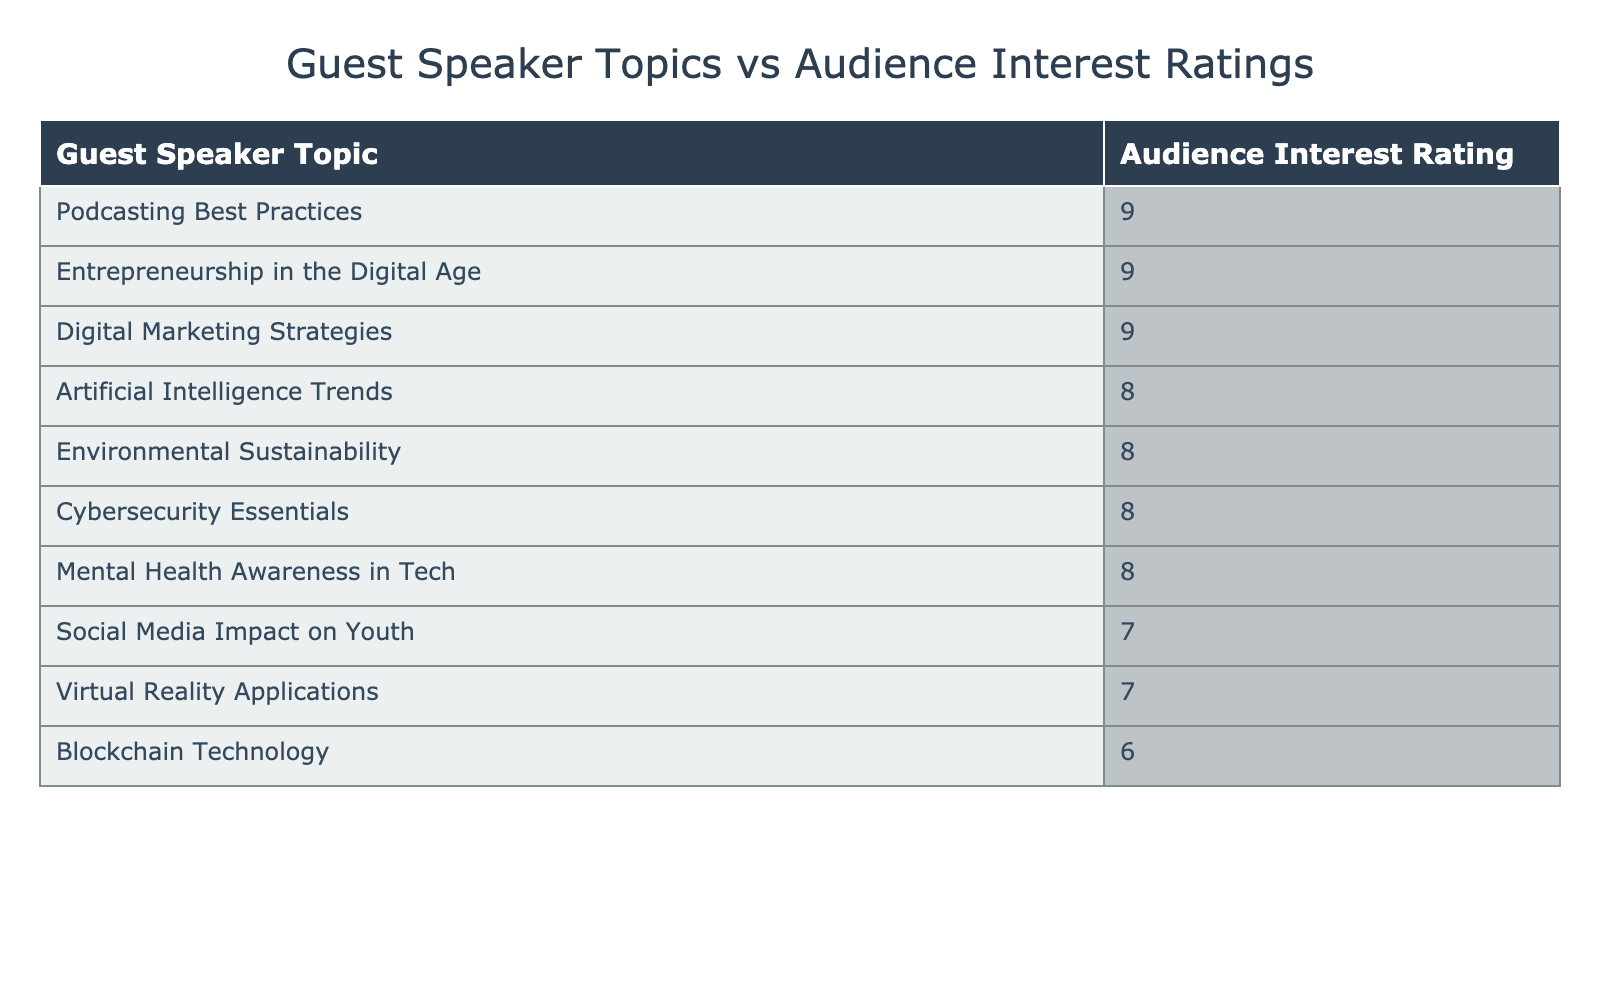What is the highest audience interest rating and which topic does it correspond to? The highest audience interest rating in the table is 9. It corresponds to the topics "Podcasting Best Practices," "Entrepreneurship in the Digital Age," and "Digital Marketing Strategies," which all share this rating.
Answer: 9 (Podcasting Best Practices, Entrepreneurship in the Digital Age, Digital Marketing Strategies) What is the audience interest rating for "Virtual Reality Applications"? The audience interest rating for "Virtual Reality Applications" is listed directly in the table as 7.
Answer: 7 How many topics received an interest rating of 8 or higher? To find this, I can count how many topics are listed with ratings of 8 or above in the table. The topics with ratings of 8 are: "Artificial Intelligence Trends," "Environmental Sustainability," "Cybersecurity Essentials," and "Mental Health Awareness in Tech." The topics with a rating of 9 are "Podcasting Best Practices," "Entrepreneurship in the Digital Age," and "Digital Marketing Strategies." In total, there are 7 topics that received 8 or higher.
Answer: 7 Was "Blockchain Technology" rated lower than "Social Media Impact on Youth"? "Blockchain Technology" has an audience interest rating of 6, while "Social Media Impact on Youth" has a rating of 7. Since 6 is less than 7, it confirms that "Blockchain Technology" was rated lower.
Answer: Yes What is the average audience interest rating across all topics? I will sum the ratings for each topic: 8 + 9 + 7 + 8 + 6 + 9 + 7 + 8 + 9 + 8 = 79. There are 10 topics in total, so the average rating is 79 divided by 10, which is 7.9.
Answer: 7.9 